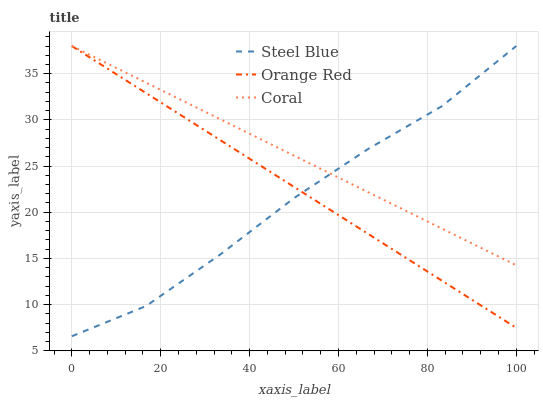Does Steel Blue have the minimum area under the curve?
Answer yes or no. Yes. Does Coral have the maximum area under the curve?
Answer yes or no. Yes. Does Orange Red have the minimum area under the curve?
Answer yes or no. No. Does Orange Red have the maximum area under the curve?
Answer yes or no. No. Is Coral the smoothest?
Answer yes or no. Yes. Is Steel Blue the roughest?
Answer yes or no. Yes. Is Orange Red the smoothest?
Answer yes or no. No. Is Orange Red the roughest?
Answer yes or no. No. Does Steel Blue have the lowest value?
Answer yes or no. Yes. Does Orange Red have the lowest value?
Answer yes or no. No. Does Orange Red have the highest value?
Answer yes or no. Yes. Does Coral intersect Orange Red?
Answer yes or no. Yes. Is Coral less than Orange Red?
Answer yes or no. No. Is Coral greater than Orange Red?
Answer yes or no. No. 